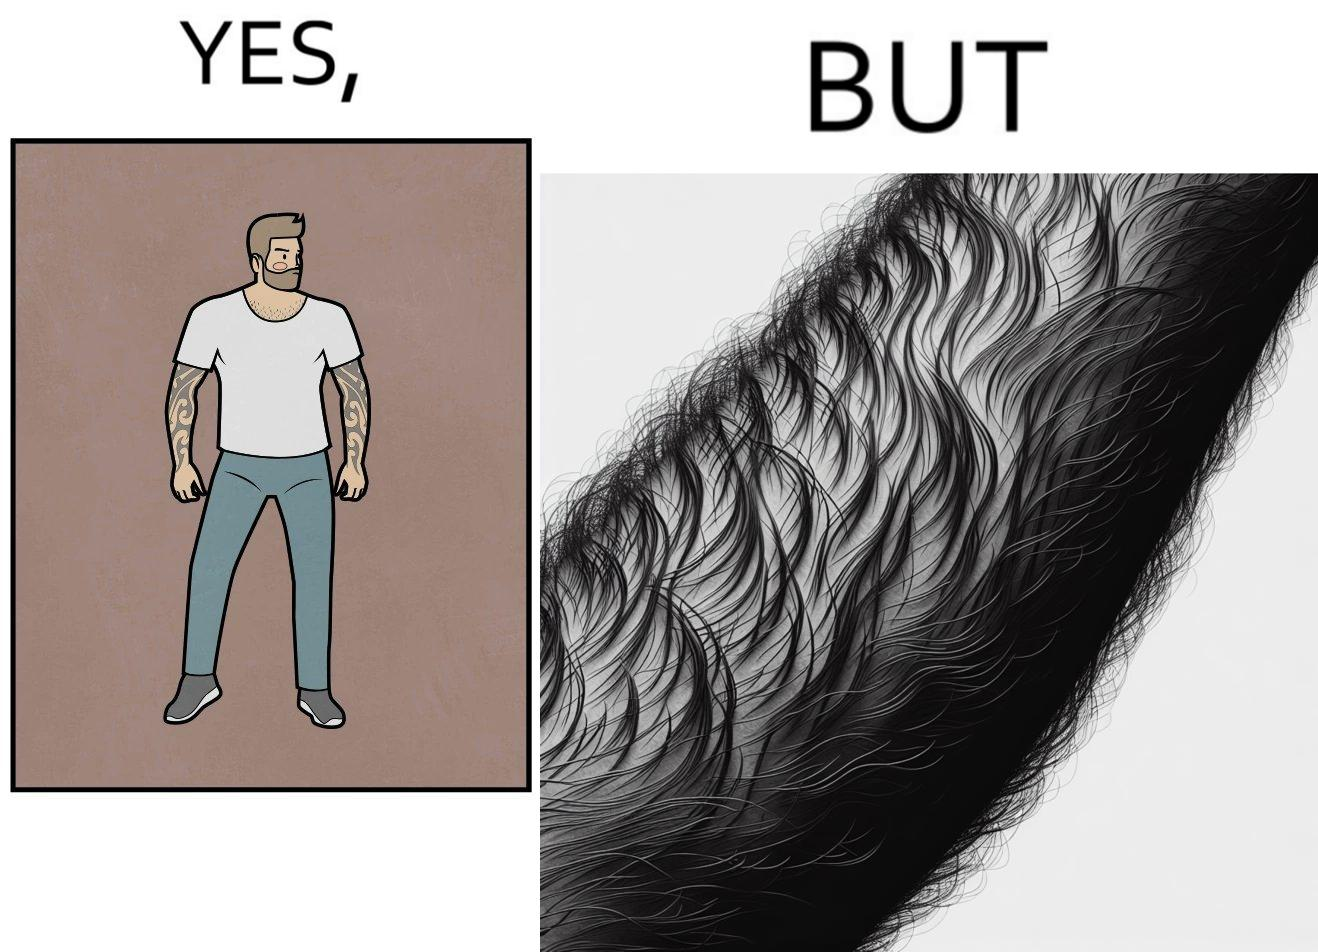Describe what you see in the left and right parts of this image. In the left part of the image: The image shows a man with tattoos on both of his arms. He is wearing white T-shirt . In the right part of the image: The image shows a closeup of an arm. The arm is shown to be very hairy and the hairs are wavy. 